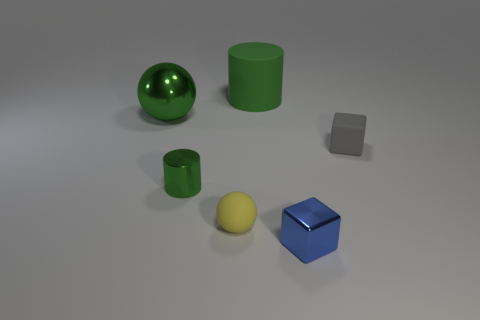There is a green thing that is the same material as the tiny gray object; what size is it?
Keep it short and to the point. Large. Do the small gray matte thing and the green rubber object have the same shape?
Your answer should be very brief. No. There is a thing that is the same size as the green sphere; what is its color?
Offer a very short reply. Green. There is a blue thing that is the same shape as the gray rubber object; what is its size?
Ensure brevity in your answer.  Small. There is a green object that is in front of the small rubber cube; what shape is it?
Provide a short and direct response. Cylinder. Does the large shiny object have the same shape as the green object that is in front of the tiny rubber cube?
Offer a terse response. No. Is the number of big green cylinders behind the blue thing the same as the number of small cylinders right of the tiny matte cube?
Give a very brief answer. No. What shape is the tiny object that is the same color as the shiny sphere?
Your answer should be compact. Cylinder. There is a sphere that is behind the yellow sphere; is it the same color as the thing that is behind the metal ball?
Provide a succinct answer. Yes. Is the number of matte things that are behind the gray rubber thing greater than the number of tiny purple metallic things?
Make the answer very short. Yes. 